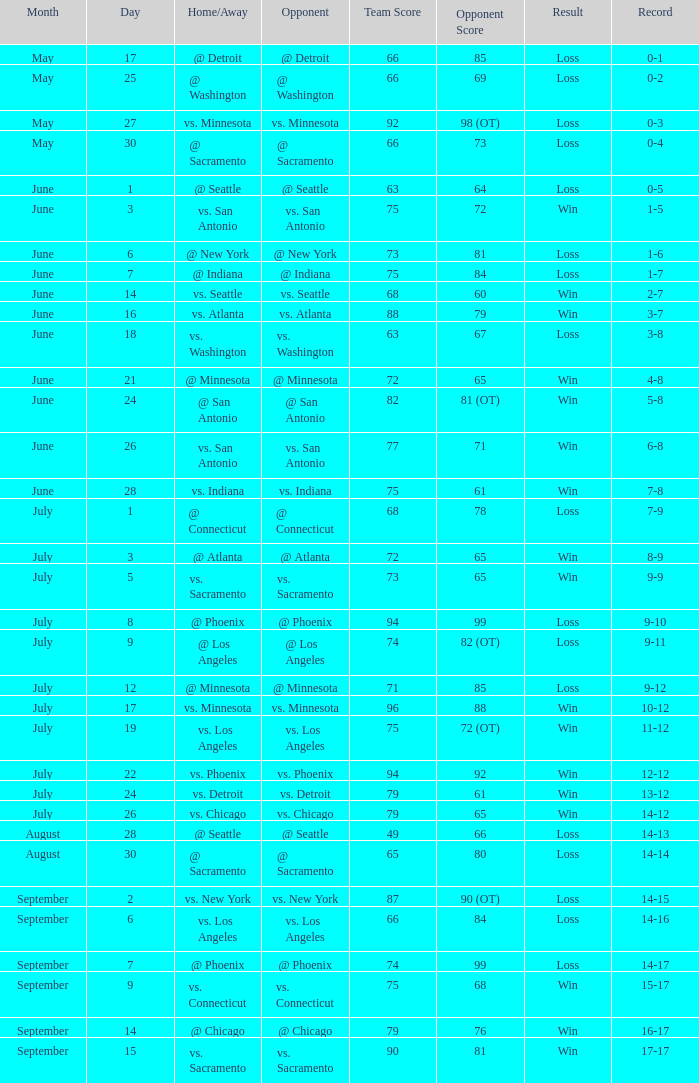What was the conclusion on may 30? Loss. 